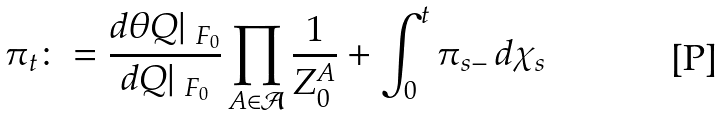<formula> <loc_0><loc_0><loc_500><loc_500>\pi _ { t } \colon = \frac { d \theta Q | _ { \ F _ { 0 } } } { d Q | _ { \ F _ { 0 } } } \prod _ { A \in \mathcal { A } } \frac { 1 } { Z _ { 0 } ^ { A } } + \int _ { 0 } ^ { t } \pi _ { s - } \, d \chi _ { s }</formula> 